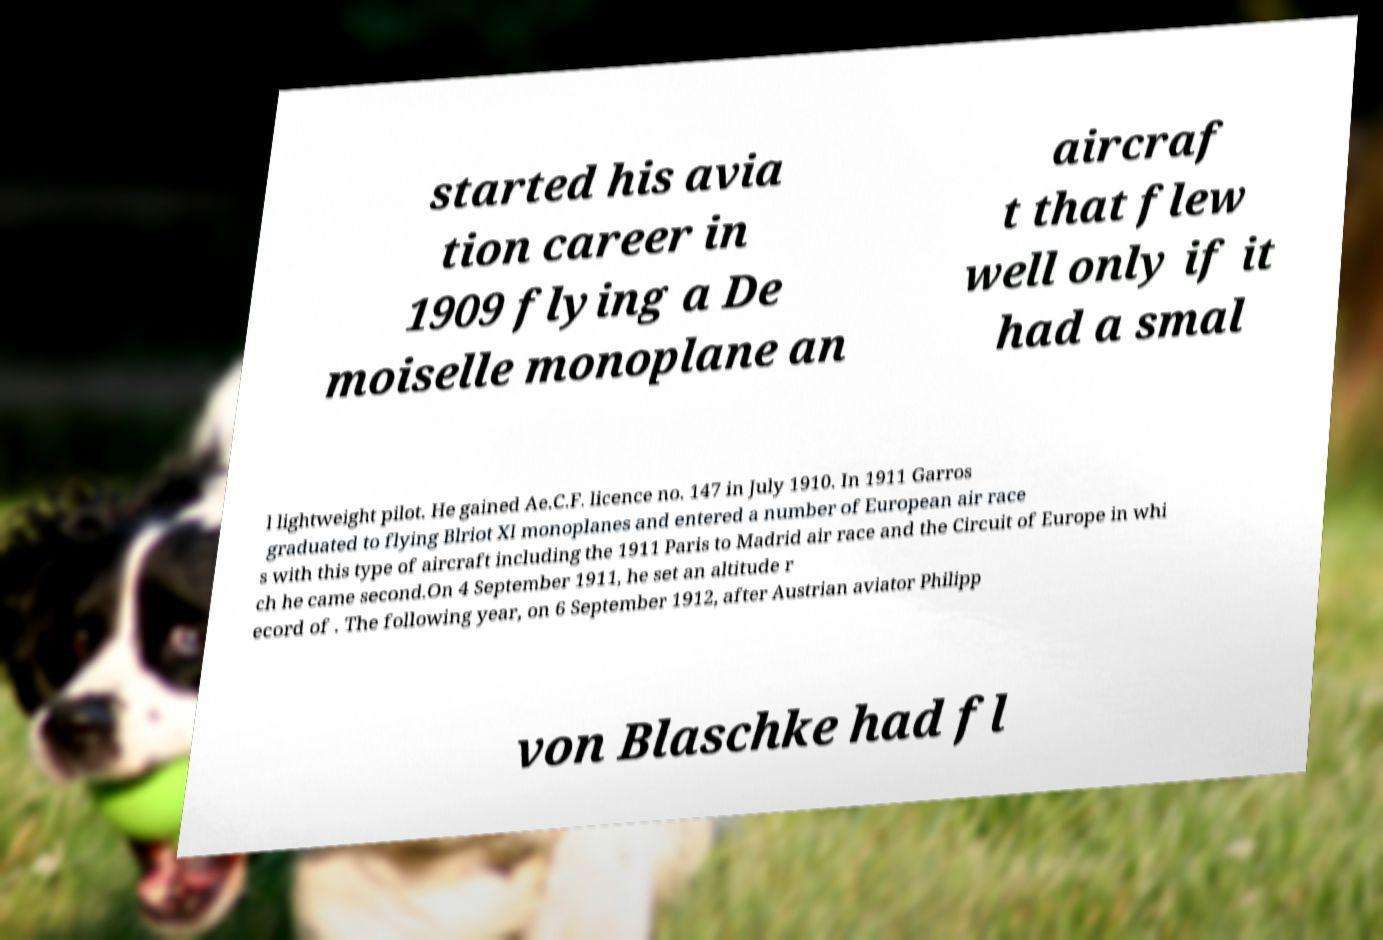What messages or text are displayed in this image? I need them in a readable, typed format. started his avia tion career in 1909 flying a De moiselle monoplane an aircraf t that flew well only if it had a smal l lightweight pilot. He gained Ae.C.F. licence no. 147 in July 1910. In 1911 Garros graduated to flying Blriot XI monoplanes and entered a number of European air race s with this type of aircraft including the 1911 Paris to Madrid air race and the Circuit of Europe in whi ch he came second.On 4 September 1911, he set an altitude r ecord of . The following year, on 6 September 1912, after Austrian aviator Philipp von Blaschke had fl 